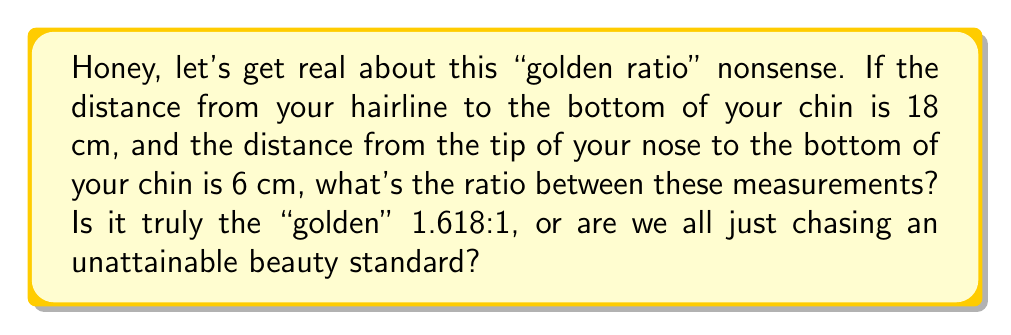Give your solution to this math problem. Alright, beauty buffs, let's break this down without the marketing fluff:

1) We have two measurements:
   - Hairline to chin: 18 cm
   - Nose tip to chin: 6 cm

2) To find the ratio, we divide the larger measurement by the smaller:

   $$ \text{Ratio} = \frac{\text{Hairline to chin}}{\text{Nose tip to chin}} = \frac{18 \text{ cm}}{6 \text{ cm}} $$

3) Simplify this fraction:

   $$ \frac{18}{6} = 3 $$

4) So, the actual ratio is 3:1.

5) The golden ratio, approximately 1.618:1, can be expressed as:

   $$ \frac{1 + \sqrt{5}}{2} \approx 1.618 $$

6) Clearly, 3 is not equal to 1.618. It's not even close, darlings.

[asy]
size(200);
draw((0,0)--(0,18),Arrow);
draw((0,0)--(6,0),Arrow);
label("18 cm", (0,9), W);
label("6 cm", (3,0), S);
dot((0,0));
dot((0,18));
dot((0,12));
label("Hairline", (0,18), E);
label("Nose", (0,12), E);
label("Chin", (0,0), E);
[/asy]
Answer: 3:1 